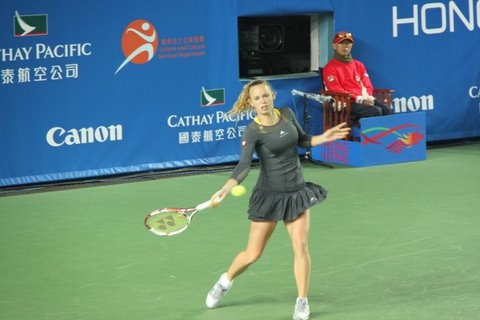Describe the objects in this image and their specific colors. I can see people in darkblue, gray, tan, olive, and black tones, people in darkblue, brown, black, and salmon tones, tennis racket in darkblue, olive, lightgreen, and beige tones, chair in darkblue, maroon, black, and gray tones, and sports ball in darkblue, khaki, and lightgreen tones in this image. 